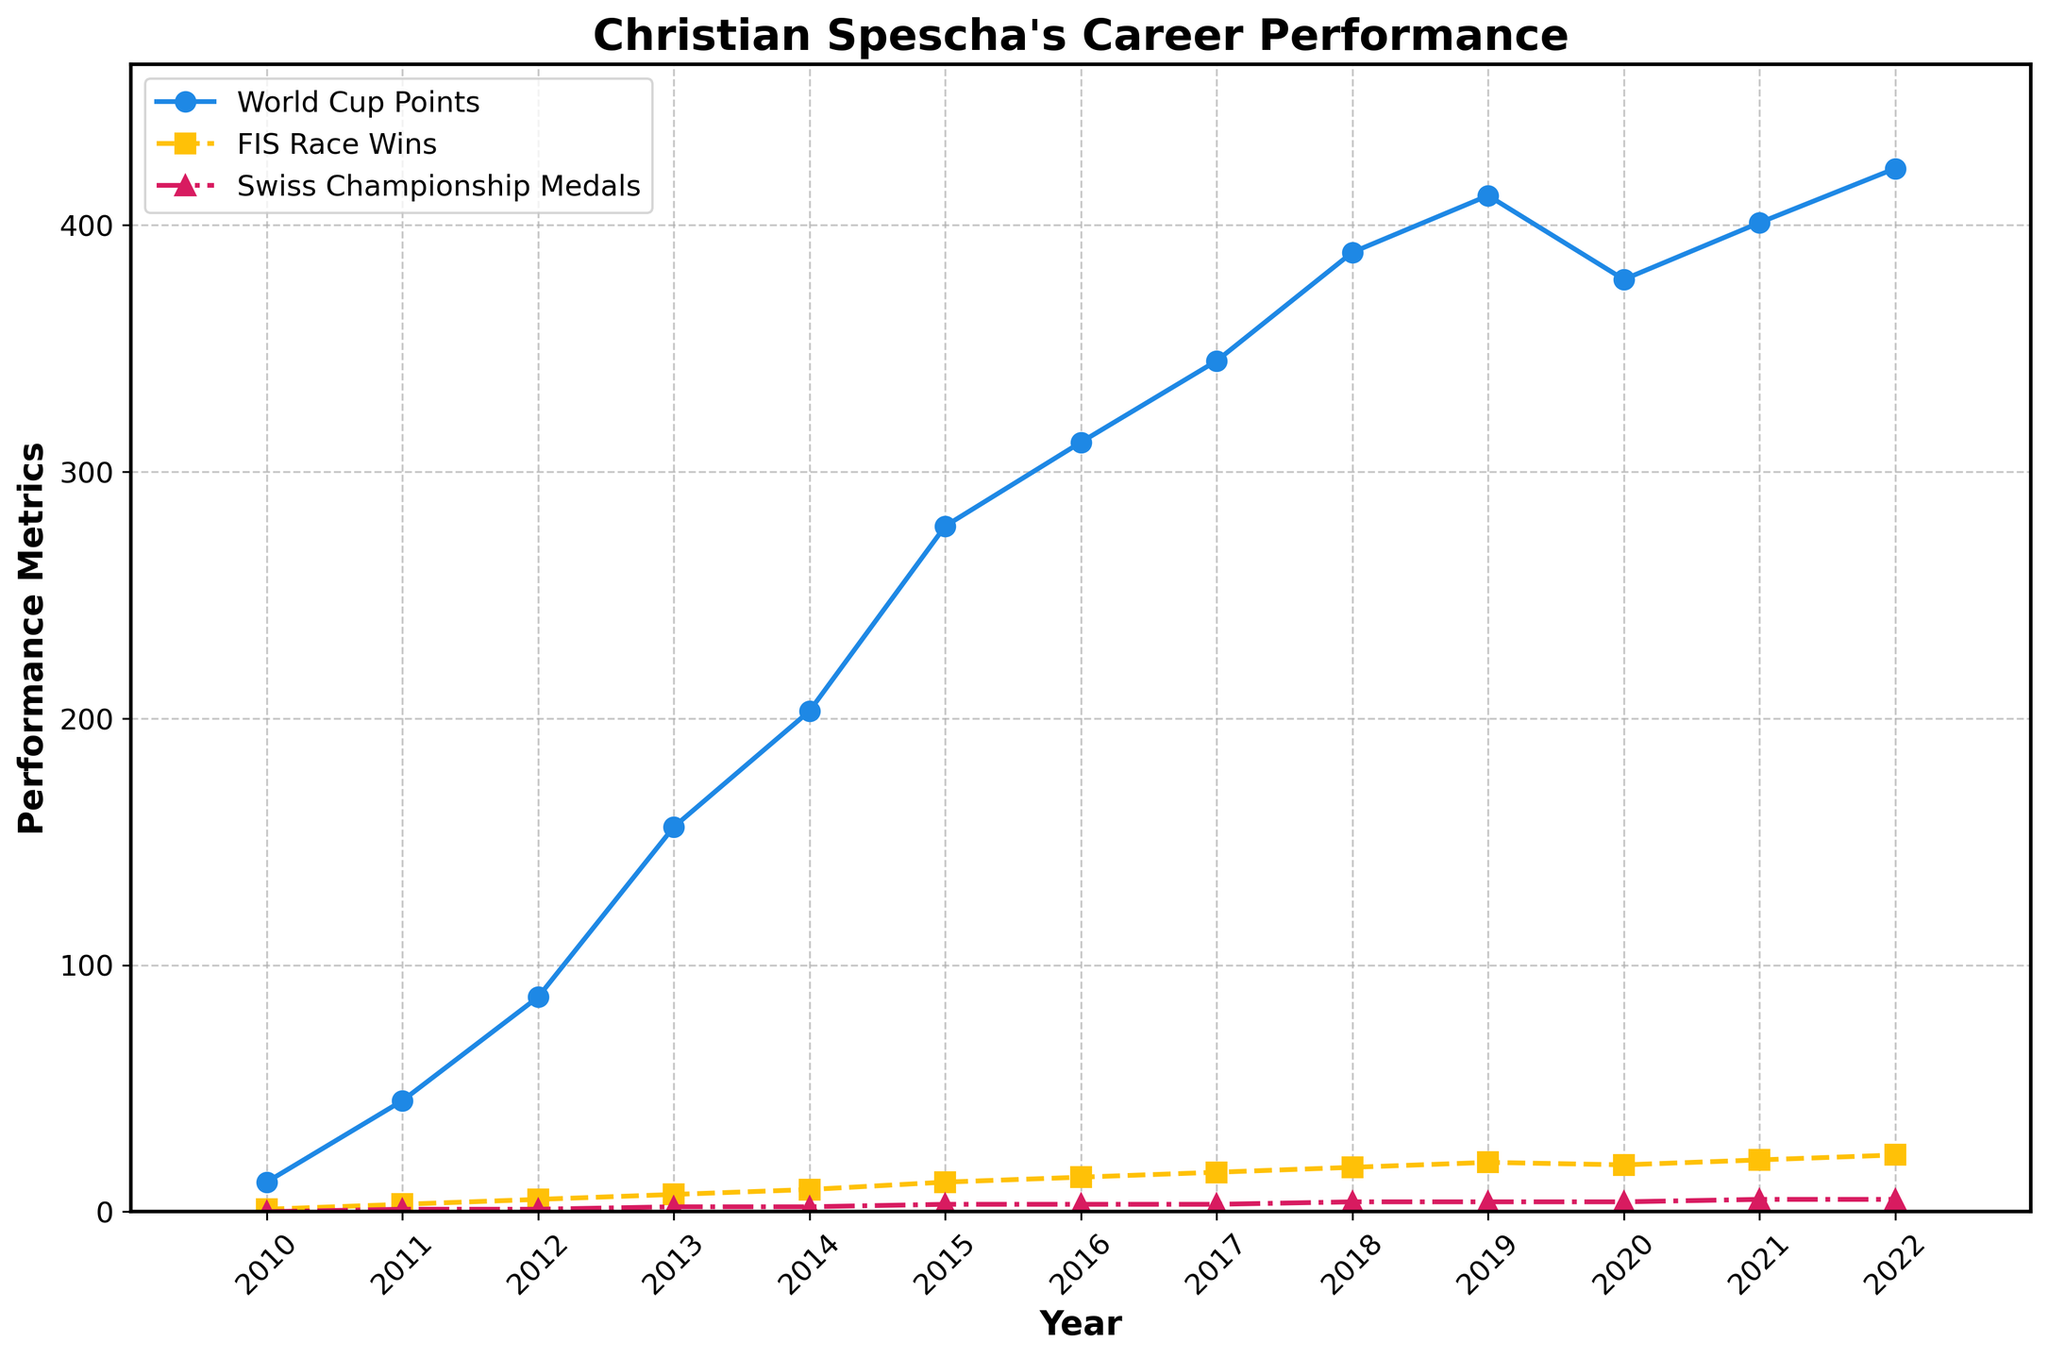How many World Cup points did Christian Spescha earn in 2015, and how does this compare to his 2019 points? First, find the World Cup points for 2015, which is 278. Then find the points for 2019, which is 412. Subtract 278 from 412 to get the difference of 134 points.
Answer: 134 points more in 2019 Which year did Christian Spescha win the most FIS races and how many did he win? Look at the plot line for "FIS Race Wins" and identify the peak year, which is 2022 with 23 wins.
Answer: 2022, 23 wins By how much did Christian Spescha’s Swiss Championship medals increase from 2013 to 2021? Identify the medals in 2013 (2) and 2021 (5). Subtract the 2013 value from the 2021 value; 5 - 2 = 3.
Answer: Increased by 3 In which year did Christian Spescha have his biggest drop in World Cup points, and what was the difference? Compare consecutive years and identify that the largest drop is from 2019 to 2020, from 412 to 378, a difference of 34 points.
Answer: 2020, dropped by 34 points What is the total number of Swiss Championship medals Christian Spescha collected between 2010 and 2022? Sum the "Swiss Championship Medals" from 2010 to 2022: 0 + 1 + 1 + 2 + 2 + 3 + 3 + 3 + 4 + 4 + 4 + 5 + 5 = 37.
Answer: 37 medals Did Christian Spescha earn more World Cup points in 2016 or 2021, and by how many? Look at the World Cup points for 2016 (312) and 2021 (401). Subtract the smaller from the larger; 401 - 312 = 89.
Answer: 2021, by 89 points How did the trend in FIS race wins change from 2018 to 2020? Observe the "FIS Race Wins" from 2018 to 2020. Wins increased from 18 (2018) to 20 (2019) and then decreased to 19 (2020).
Answer: Increased then slightly decreased In which years did the number of Swiss Championship medals remain constant, and at what value? Identify years where the medals did not change: 2015, 2016 and 2017 with 3 medals each.
Answer: 2015, 2016, 2017, all with 3 medals What is the average World Cup points Christian Spescha earned over his career from 2010 to 2022? Sum all World Cup points from 2010 to 2022 and divide by the number of years: (12 + 45 + 87 + 156 + 203 + 278 + 312 + 345 + 389 + 412 + 378 + 401 + 423) / 13 = 272 points.
Answer: 272 points How many more FIS race wins did Christian Spescha achieve in 2022 compared to 2016? Find the "FIS Race Wins" values for 2022 (23) and 2016 (14). Subtract 14 from 23; 23 - 14 = 9.
Answer: 9 more wins 